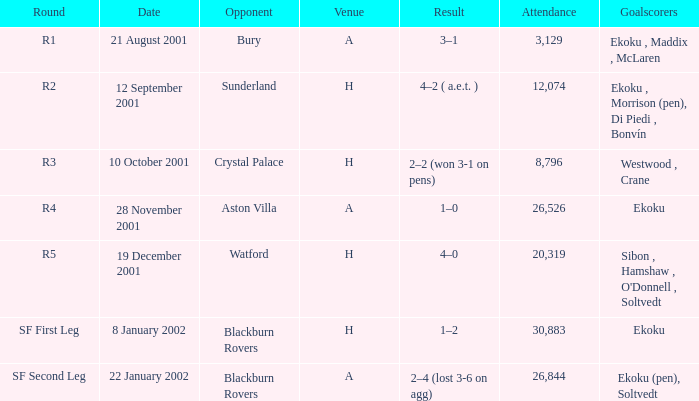Which result has sunderland as opponent? 4–2 ( a.e.t. ). 